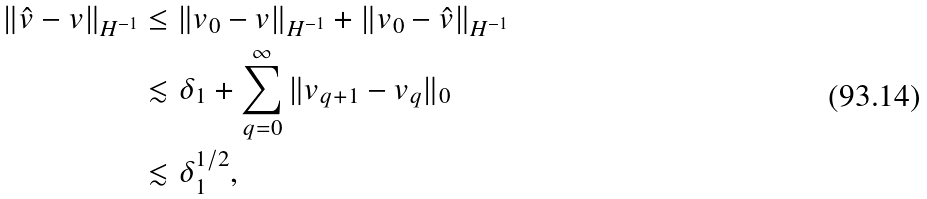Convert formula to latex. <formula><loc_0><loc_0><loc_500><loc_500>\| \hat { v } - v \| _ { H ^ { - 1 } } & \leq \| v _ { 0 } - v \| _ { H ^ { - 1 } } + \| v _ { 0 } - \hat { v } \| _ { H ^ { - 1 } } \\ & \lesssim \delta _ { 1 } + \sum _ { q = 0 } ^ { \infty } \| v _ { q + 1 } - v _ { q } \| _ { 0 } \\ & \lesssim \delta _ { 1 } ^ { 1 / 2 } ,</formula> 